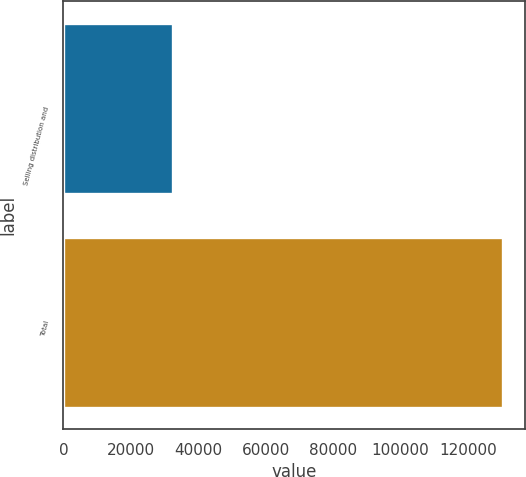Convert chart to OTSL. <chart><loc_0><loc_0><loc_500><loc_500><bar_chart><fcel>Selling distribution and<fcel>Total<nl><fcel>32547<fcel>130339<nl></chart> 